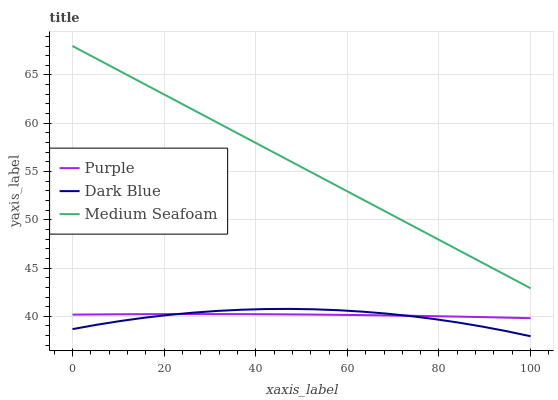Does Dark Blue have the minimum area under the curve?
Answer yes or no. Yes. Does Medium Seafoam have the maximum area under the curve?
Answer yes or no. Yes. Does Medium Seafoam have the minimum area under the curve?
Answer yes or no. No. Does Dark Blue have the maximum area under the curve?
Answer yes or no. No. Is Medium Seafoam the smoothest?
Answer yes or no. Yes. Is Dark Blue the roughest?
Answer yes or no. Yes. Is Dark Blue the smoothest?
Answer yes or no. No. Is Medium Seafoam the roughest?
Answer yes or no. No. Does Dark Blue have the lowest value?
Answer yes or no. Yes. Does Medium Seafoam have the lowest value?
Answer yes or no. No. Does Medium Seafoam have the highest value?
Answer yes or no. Yes. Does Dark Blue have the highest value?
Answer yes or no. No. Is Dark Blue less than Medium Seafoam?
Answer yes or no. Yes. Is Medium Seafoam greater than Dark Blue?
Answer yes or no. Yes. Does Purple intersect Dark Blue?
Answer yes or no. Yes. Is Purple less than Dark Blue?
Answer yes or no. No. Is Purple greater than Dark Blue?
Answer yes or no. No. Does Dark Blue intersect Medium Seafoam?
Answer yes or no. No. 